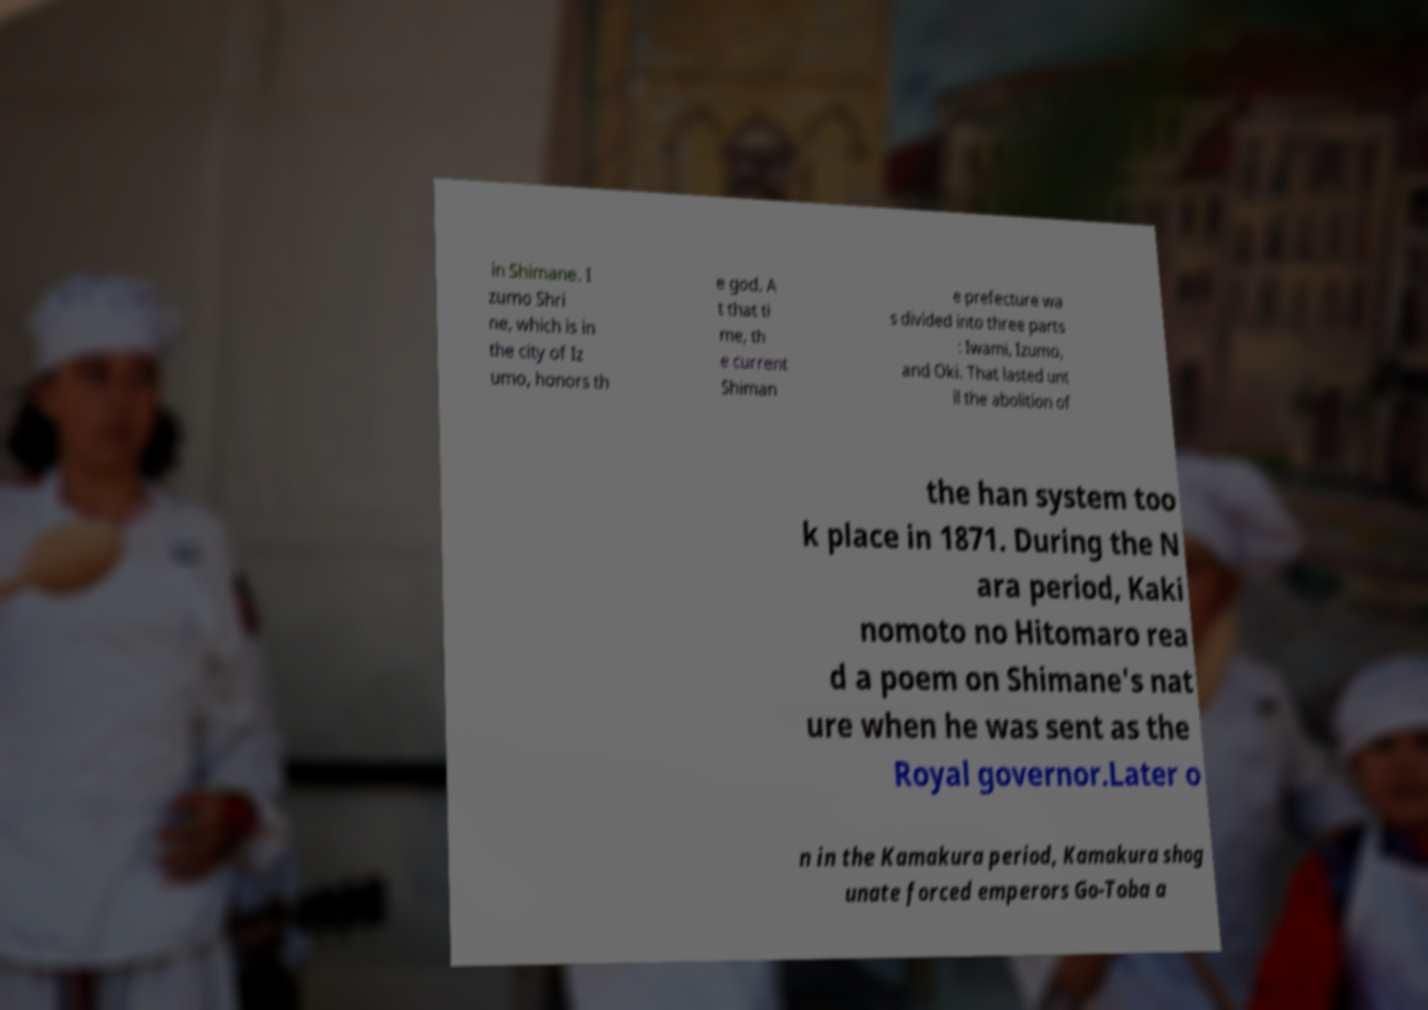What messages or text are displayed in this image? I need them in a readable, typed format. in Shimane. I zumo Shri ne, which is in the city of Iz umo, honors th e god. A t that ti me, th e current Shiman e prefecture wa s divided into three parts : Iwami, Izumo, and Oki. That lasted unt il the abolition of the han system too k place in 1871. During the N ara period, Kaki nomoto no Hitomaro rea d a poem on Shimane's nat ure when he was sent as the Royal governor.Later o n in the Kamakura period, Kamakura shog unate forced emperors Go-Toba a 